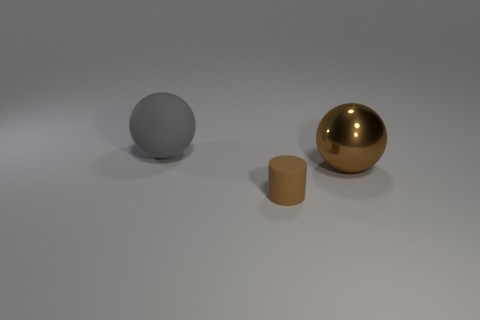Add 1 large rubber objects. How many objects exist? 4 Subtract all cylinders. How many objects are left? 2 Add 2 tiny brown matte objects. How many tiny brown matte objects exist? 3 Subtract 0 gray cylinders. How many objects are left? 3 Subtract all gray rubber spheres. Subtract all tiny yellow shiny blocks. How many objects are left? 2 Add 2 large matte balls. How many large matte balls are left? 3 